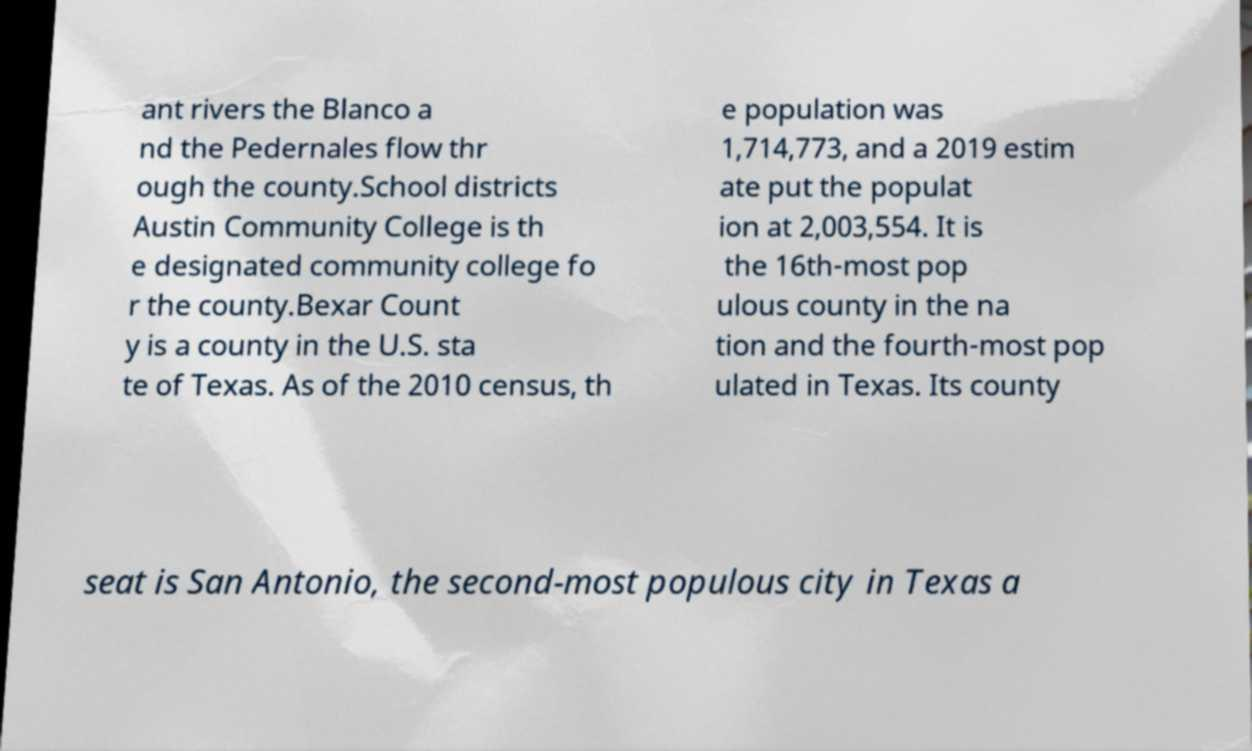Can you read and provide the text displayed in the image?This photo seems to have some interesting text. Can you extract and type it out for me? ant rivers the Blanco a nd the Pedernales flow thr ough the county.School districts Austin Community College is th e designated community college fo r the county.Bexar Count y is a county in the U.S. sta te of Texas. As of the 2010 census, th e population was 1,714,773, and a 2019 estim ate put the populat ion at 2,003,554. It is the 16th-most pop ulous county in the na tion and the fourth-most pop ulated in Texas. Its county seat is San Antonio, the second-most populous city in Texas a 